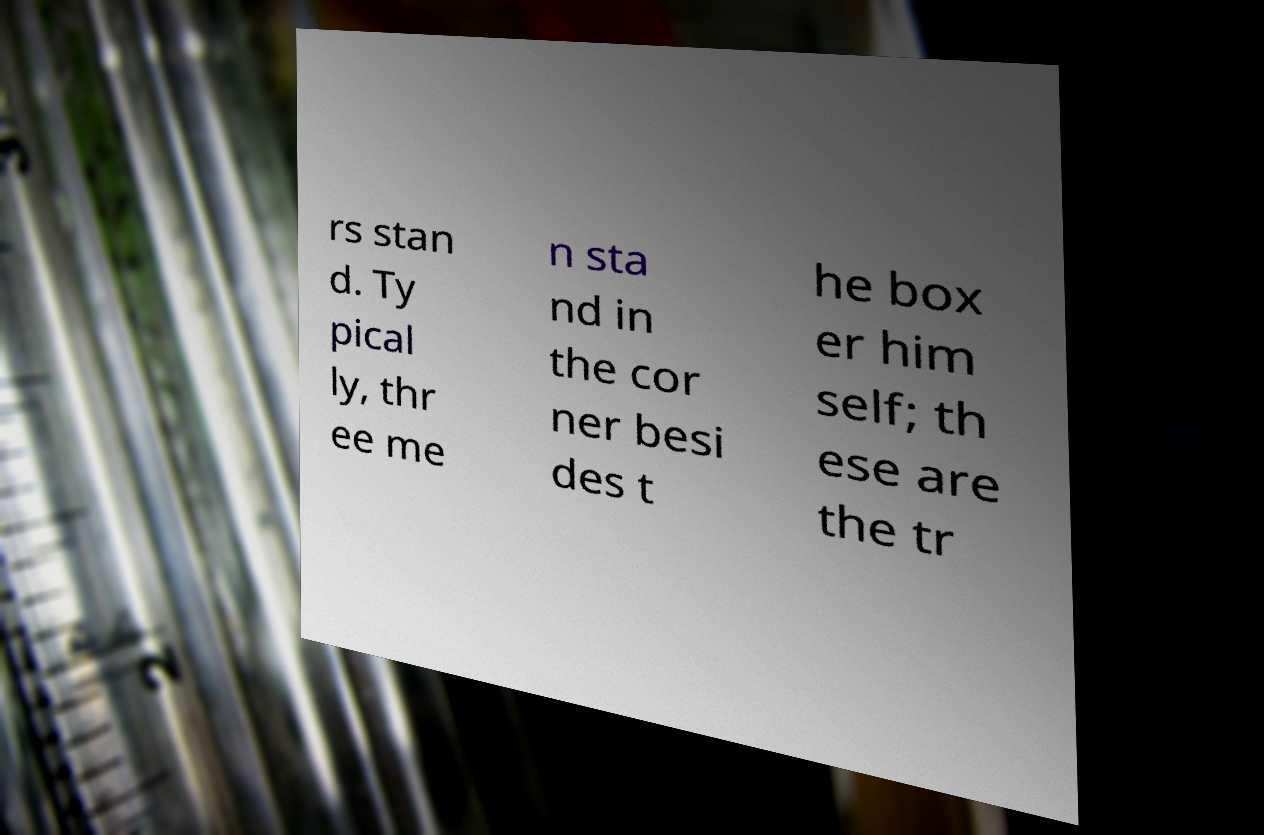There's text embedded in this image that I need extracted. Can you transcribe it verbatim? rs stan d. Ty pical ly, thr ee me n sta nd in the cor ner besi des t he box er him self; th ese are the tr 